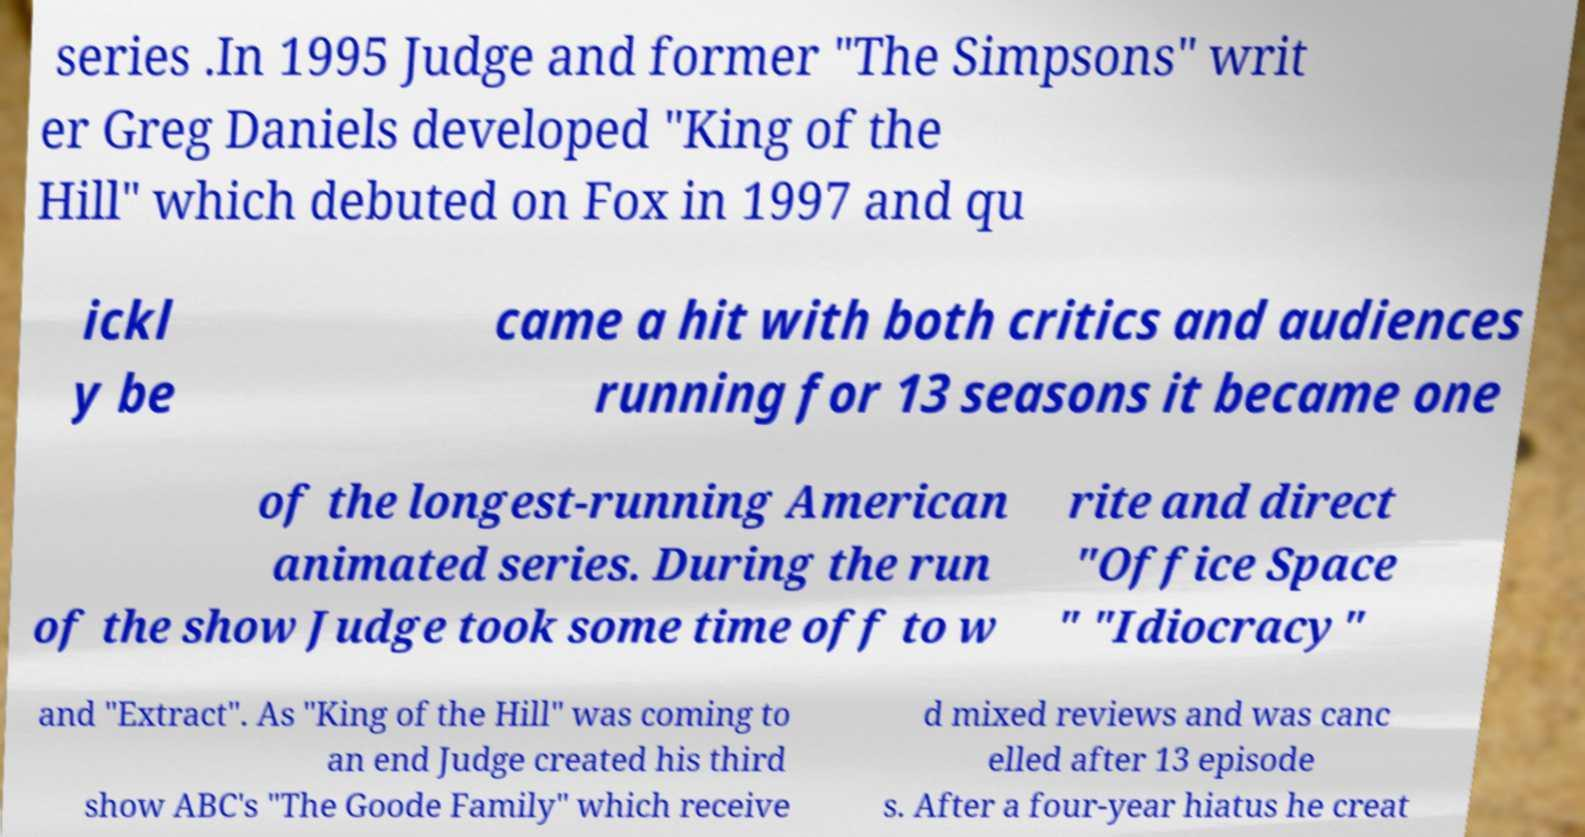Could you extract and type out the text from this image? series .In 1995 Judge and former "The Simpsons" writ er Greg Daniels developed "King of the Hill" which debuted on Fox in 1997 and qu ickl y be came a hit with both critics and audiences running for 13 seasons it became one of the longest-running American animated series. During the run of the show Judge took some time off to w rite and direct "Office Space " "Idiocracy" and "Extract". As "King of the Hill" was coming to an end Judge created his third show ABC's "The Goode Family" which receive d mixed reviews and was canc elled after 13 episode s. After a four-year hiatus he creat 